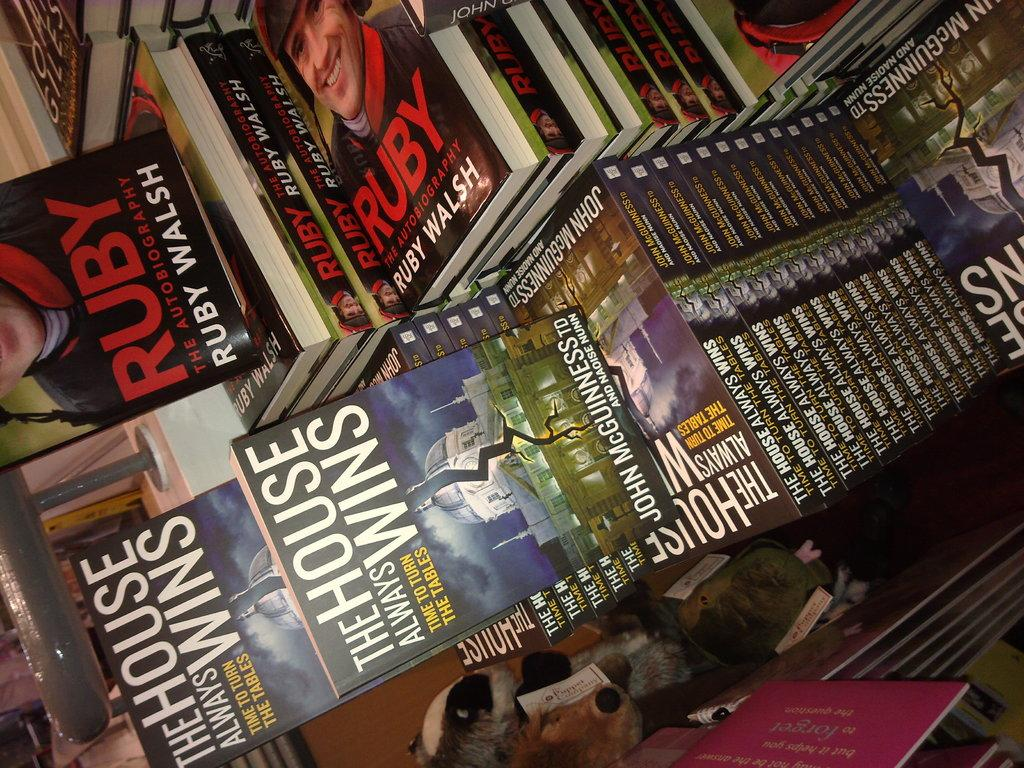<image>
Share a concise interpretation of the image provided. Stacks of a book titled Ruby are surrounded by other books as well. 